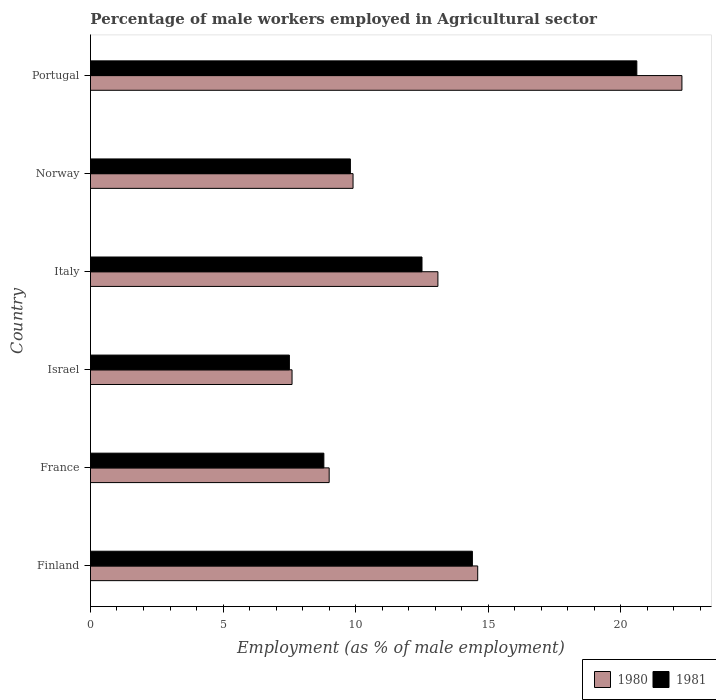How many different coloured bars are there?
Give a very brief answer. 2. Are the number of bars per tick equal to the number of legend labels?
Offer a terse response. Yes. How many bars are there on the 4th tick from the top?
Ensure brevity in your answer.  2. What is the label of the 6th group of bars from the top?
Your answer should be compact. Finland. What is the percentage of male workers employed in Agricultural sector in 1980 in Finland?
Ensure brevity in your answer.  14.6. Across all countries, what is the maximum percentage of male workers employed in Agricultural sector in 1981?
Provide a succinct answer. 20.6. Across all countries, what is the minimum percentage of male workers employed in Agricultural sector in 1980?
Provide a short and direct response. 7.6. In which country was the percentage of male workers employed in Agricultural sector in 1980 maximum?
Ensure brevity in your answer.  Portugal. In which country was the percentage of male workers employed in Agricultural sector in 1981 minimum?
Your answer should be very brief. Israel. What is the total percentage of male workers employed in Agricultural sector in 1981 in the graph?
Your answer should be compact. 73.6. What is the difference between the percentage of male workers employed in Agricultural sector in 1980 in Finland and that in Portugal?
Provide a short and direct response. -7.7. What is the difference between the percentage of male workers employed in Agricultural sector in 1981 in Italy and the percentage of male workers employed in Agricultural sector in 1980 in Israel?
Give a very brief answer. 4.9. What is the average percentage of male workers employed in Agricultural sector in 1980 per country?
Your response must be concise. 12.75. What is the difference between the percentage of male workers employed in Agricultural sector in 1980 and percentage of male workers employed in Agricultural sector in 1981 in Italy?
Your answer should be very brief. 0.6. In how many countries, is the percentage of male workers employed in Agricultural sector in 1981 greater than 14 %?
Offer a very short reply. 2. What is the ratio of the percentage of male workers employed in Agricultural sector in 1981 in Finland to that in Italy?
Your response must be concise. 1.15. What is the difference between the highest and the second highest percentage of male workers employed in Agricultural sector in 1980?
Offer a very short reply. 7.7. What is the difference between the highest and the lowest percentage of male workers employed in Agricultural sector in 1981?
Your response must be concise. 13.1. In how many countries, is the percentage of male workers employed in Agricultural sector in 1981 greater than the average percentage of male workers employed in Agricultural sector in 1981 taken over all countries?
Provide a short and direct response. 3. Is the sum of the percentage of male workers employed in Agricultural sector in 1981 in Israel and Norway greater than the maximum percentage of male workers employed in Agricultural sector in 1980 across all countries?
Ensure brevity in your answer.  No. Does the graph contain any zero values?
Offer a terse response. No. How many legend labels are there?
Provide a succinct answer. 2. How are the legend labels stacked?
Give a very brief answer. Horizontal. What is the title of the graph?
Ensure brevity in your answer.  Percentage of male workers employed in Agricultural sector. Does "1972" appear as one of the legend labels in the graph?
Provide a succinct answer. No. What is the label or title of the X-axis?
Offer a very short reply. Employment (as % of male employment). What is the Employment (as % of male employment) of 1980 in Finland?
Your response must be concise. 14.6. What is the Employment (as % of male employment) in 1981 in Finland?
Your answer should be compact. 14.4. What is the Employment (as % of male employment) in 1980 in France?
Offer a very short reply. 9. What is the Employment (as % of male employment) of 1981 in France?
Provide a short and direct response. 8.8. What is the Employment (as % of male employment) in 1980 in Israel?
Keep it short and to the point. 7.6. What is the Employment (as % of male employment) of 1980 in Italy?
Give a very brief answer. 13.1. What is the Employment (as % of male employment) of 1981 in Italy?
Ensure brevity in your answer.  12.5. What is the Employment (as % of male employment) of 1980 in Norway?
Keep it short and to the point. 9.9. What is the Employment (as % of male employment) of 1981 in Norway?
Provide a succinct answer. 9.8. What is the Employment (as % of male employment) in 1980 in Portugal?
Offer a terse response. 22.3. What is the Employment (as % of male employment) of 1981 in Portugal?
Provide a short and direct response. 20.6. Across all countries, what is the maximum Employment (as % of male employment) of 1980?
Your response must be concise. 22.3. Across all countries, what is the maximum Employment (as % of male employment) in 1981?
Offer a very short reply. 20.6. Across all countries, what is the minimum Employment (as % of male employment) in 1980?
Your response must be concise. 7.6. Across all countries, what is the minimum Employment (as % of male employment) of 1981?
Make the answer very short. 7.5. What is the total Employment (as % of male employment) of 1980 in the graph?
Provide a short and direct response. 76.5. What is the total Employment (as % of male employment) of 1981 in the graph?
Make the answer very short. 73.6. What is the difference between the Employment (as % of male employment) in 1981 in Finland and that in Italy?
Your answer should be compact. 1.9. What is the difference between the Employment (as % of male employment) in 1980 in Finland and that in Norway?
Give a very brief answer. 4.7. What is the difference between the Employment (as % of male employment) in 1980 in Finland and that in Portugal?
Provide a succinct answer. -7.7. What is the difference between the Employment (as % of male employment) in 1981 in Finland and that in Portugal?
Provide a succinct answer. -6.2. What is the difference between the Employment (as % of male employment) of 1980 in France and that in Israel?
Give a very brief answer. 1.4. What is the difference between the Employment (as % of male employment) of 1981 in France and that in Israel?
Offer a very short reply. 1.3. What is the difference between the Employment (as % of male employment) of 1981 in France and that in Italy?
Ensure brevity in your answer.  -3.7. What is the difference between the Employment (as % of male employment) in 1980 in France and that in Norway?
Provide a succinct answer. -0.9. What is the difference between the Employment (as % of male employment) in 1980 in France and that in Portugal?
Offer a terse response. -13.3. What is the difference between the Employment (as % of male employment) of 1981 in France and that in Portugal?
Make the answer very short. -11.8. What is the difference between the Employment (as % of male employment) in 1980 in Israel and that in Italy?
Offer a terse response. -5.5. What is the difference between the Employment (as % of male employment) of 1980 in Israel and that in Norway?
Ensure brevity in your answer.  -2.3. What is the difference between the Employment (as % of male employment) of 1980 in Israel and that in Portugal?
Make the answer very short. -14.7. What is the difference between the Employment (as % of male employment) in 1980 in Italy and that in Norway?
Ensure brevity in your answer.  3.2. What is the difference between the Employment (as % of male employment) in 1981 in Italy and that in Norway?
Ensure brevity in your answer.  2.7. What is the difference between the Employment (as % of male employment) of 1981 in Italy and that in Portugal?
Provide a short and direct response. -8.1. What is the difference between the Employment (as % of male employment) in 1981 in Norway and that in Portugal?
Provide a succinct answer. -10.8. What is the difference between the Employment (as % of male employment) of 1980 in Finland and the Employment (as % of male employment) of 1981 in France?
Your response must be concise. 5.8. What is the difference between the Employment (as % of male employment) in 1980 in Finland and the Employment (as % of male employment) in 1981 in Italy?
Your response must be concise. 2.1. What is the difference between the Employment (as % of male employment) of 1980 in Finland and the Employment (as % of male employment) of 1981 in Portugal?
Give a very brief answer. -6. What is the difference between the Employment (as % of male employment) of 1980 in France and the Employment (as % of male employment) of 1981 in Israel?
Offer a very short reply. 1.5. What is the difference between the Employment (as % of male employment) of 1980 in France and the Employment (as % of male employment) of 1981 in Norway?
Offer a very short reply. -0.8. What is the difference between the Employment (as % of male employment) of 1980 in France and the Employment (as % of male employment) of 1981 in Portugal?
Provide a short and direct response. -11.6. What is the difference between the Employment (as % of male employment) of 1980 in Israel and the Employment (as % of male employment) of 1981 in Italy?
Your answer should be compact. -4.9. What is the difference between the Employment (as % of male employment) in 1980 in Israel and the Employment (as % of male employment) in 1981 in Norway?
Give a very brief answer. -2.2. What is the difference between the Employment (as % of male employment) of 1980 in Norway and the Employment (as % of male employment) of 1981 in Portugal?
Your response must be concise. -10.7. What is the average Employment (as % of male employment) in 1980 per country?
Keep it short and to the point. 12.75. What is the average Employment (as % of male employment) in 1981 per country?
Provide a succinct answer. 12.27. What is the difference between the Employment (as % of male employment) of 1980 and Employment (as % of male employment) of 1981 in Finland?
Keep it short and to the point. 0.2. What is the difference between the Employment (as % of male employment) of 1980 and Employment (as % of male employment) of 1981 in Israel?
Provide a short and direct response. 0.1. What is the difference between the Employment (as % of male employment) of 1980 and Employment (as % of male employment) of 1981 in Italy?
Ensure brevity in your answer.  0.6. What is the difference between the Employment (as % of male employment) of 1980 and Employment (as % of male employment) of 1981 in Norway?
Make the answer very short. 0.1. What is the difference between the Employment (as % of male employment) in 1980 and Employment (as % of male employment) in 1981 in Portugal?
Provide a succinct answer. 1.7. What is the ratio of the Employment (as % of male employment) of 1980 in Finland to that in France?
Keep it short and to the point. 1.62. What is the ratio of the Employment (as % of male employment) of 1981 in Finland to that in France?
Provide a succinct answer. 1.64. What is the ratio of the Employment (as % of male employment) in 1980 in Finland to that in Israel?
Ensure brevity in your answer.  1.92. What is the ratio of the Employment (as % of male employment) in 1981 in Finland to that in Israel?
Ensure brevity in your answer.  1.92. What is the ratio of the Employment (as % of male employment) of 1980 in Finland to that in Italy?
Make the answer very short. 1.11. What is the ratio of the Employment (as % of male employment) of 1981 in Finland to that in Italy?
Ensure brevity in your answer.  1.15. What is the ratio of the Employment (as % of male employment) of 1980 in Finland to that in Norway?
Your response must be concise. 1.47. What is the ratio of the Employment (as % of male employment) of 1981 in Finland to that in Norway?
Your answer should be very brief. 1.47. What is the ratio of the Employment (as % of male employment) in 1980 in Finland to that in Portugal?
Keep it short and to the point. 0.65. What is the ratio of the Employment (as % of male employment) in 1981 in Finland to that in Portugal?
Ensure brevity in your answer.  0.7. What is the ratio of the Employment (as % of male employment) of 1980 in France to that in Israel?
Ensure brevity in your answer.  1.18. What is the ratio of the Employment (as % of male employment) in 1981 in France to that in Israel?
Keep it short and to the point. 1.17. What is the ratio of the Employment (as % of male employment) in 1980 in France to that in Italy?
Offer a terse response. 0.69. What is the ratio of the Employment (as % of male employment) of 1981 in France to that in Italy?
Offer a terse response. 0.7. What is the ratio of the Employment (as % of male employment) in 1981 in France to that in Norway?
Make the answer very short. 0.9. What is the ratio of the Employment (as % of male employment) in 1980 in France to that in Portugal?
Offer a very short reply. 0.4. What is the ratio of the Employment (as % of male employment) of 1981 in France to that in Portugal?
Provide a succinct answer. 0.43. What is the ratio of the Employment (as % of male employment) in 1980 in Israel to that in Italy?
Your answer should be compact. 0.58. What is the ratio of the Employment (as % of male employment) of 1980 in Israel to that in Norway?
Offer a very short reply. 0.77. What is the ratio of the Employment (as % of male employment) of 1981 in Israel to that in Norway?
Your answer should be compact. 0.77. What is the ratio of the Employment (as % of male employment) in 1980 in Israel to that in Portugal?
Your answer should be compact. 0.34. What is the ratio of the Employment (as % of male employment) of 1981 in Israel to that in Portugal?
Give a very brief answer. 0.36. What is the ratio of the Employment (as % of male employment) in 1980 in Italy to that in Norway?
Make the answer very short. 1.32. What is the ratio of the Employment (as % of male employment) in 1981 in Italy to that in Norway?
Offer a very short reply. 1.28. What is the ratio of the Employment (as % of male employment) of 1980 in Italy to that in Portugal?
Provide a short and direct response. 0.59. What is the ratio of the Employment (as % of male employment) of 1981 in Italy to that in Portugal?
Your answer should be compact. 0.61. What is the ratio of the Employment (as % of male employment) in 1980 in Norway to that in Portugal?
Offer a very short reply. 0.44. What is the ratio of the Employment (as % of male employment) of 1981 in Norway to that in Portugal?
Give a very brief answer. 0.48. What is the difference between the highest and the second highest Employment (as % of male employment) in 1980?
Offer a terse response. 7.7. What is the difference between the highest and the second highest Employment (as % of male employment) of 1981?
Make the answer very short. 6.2. 